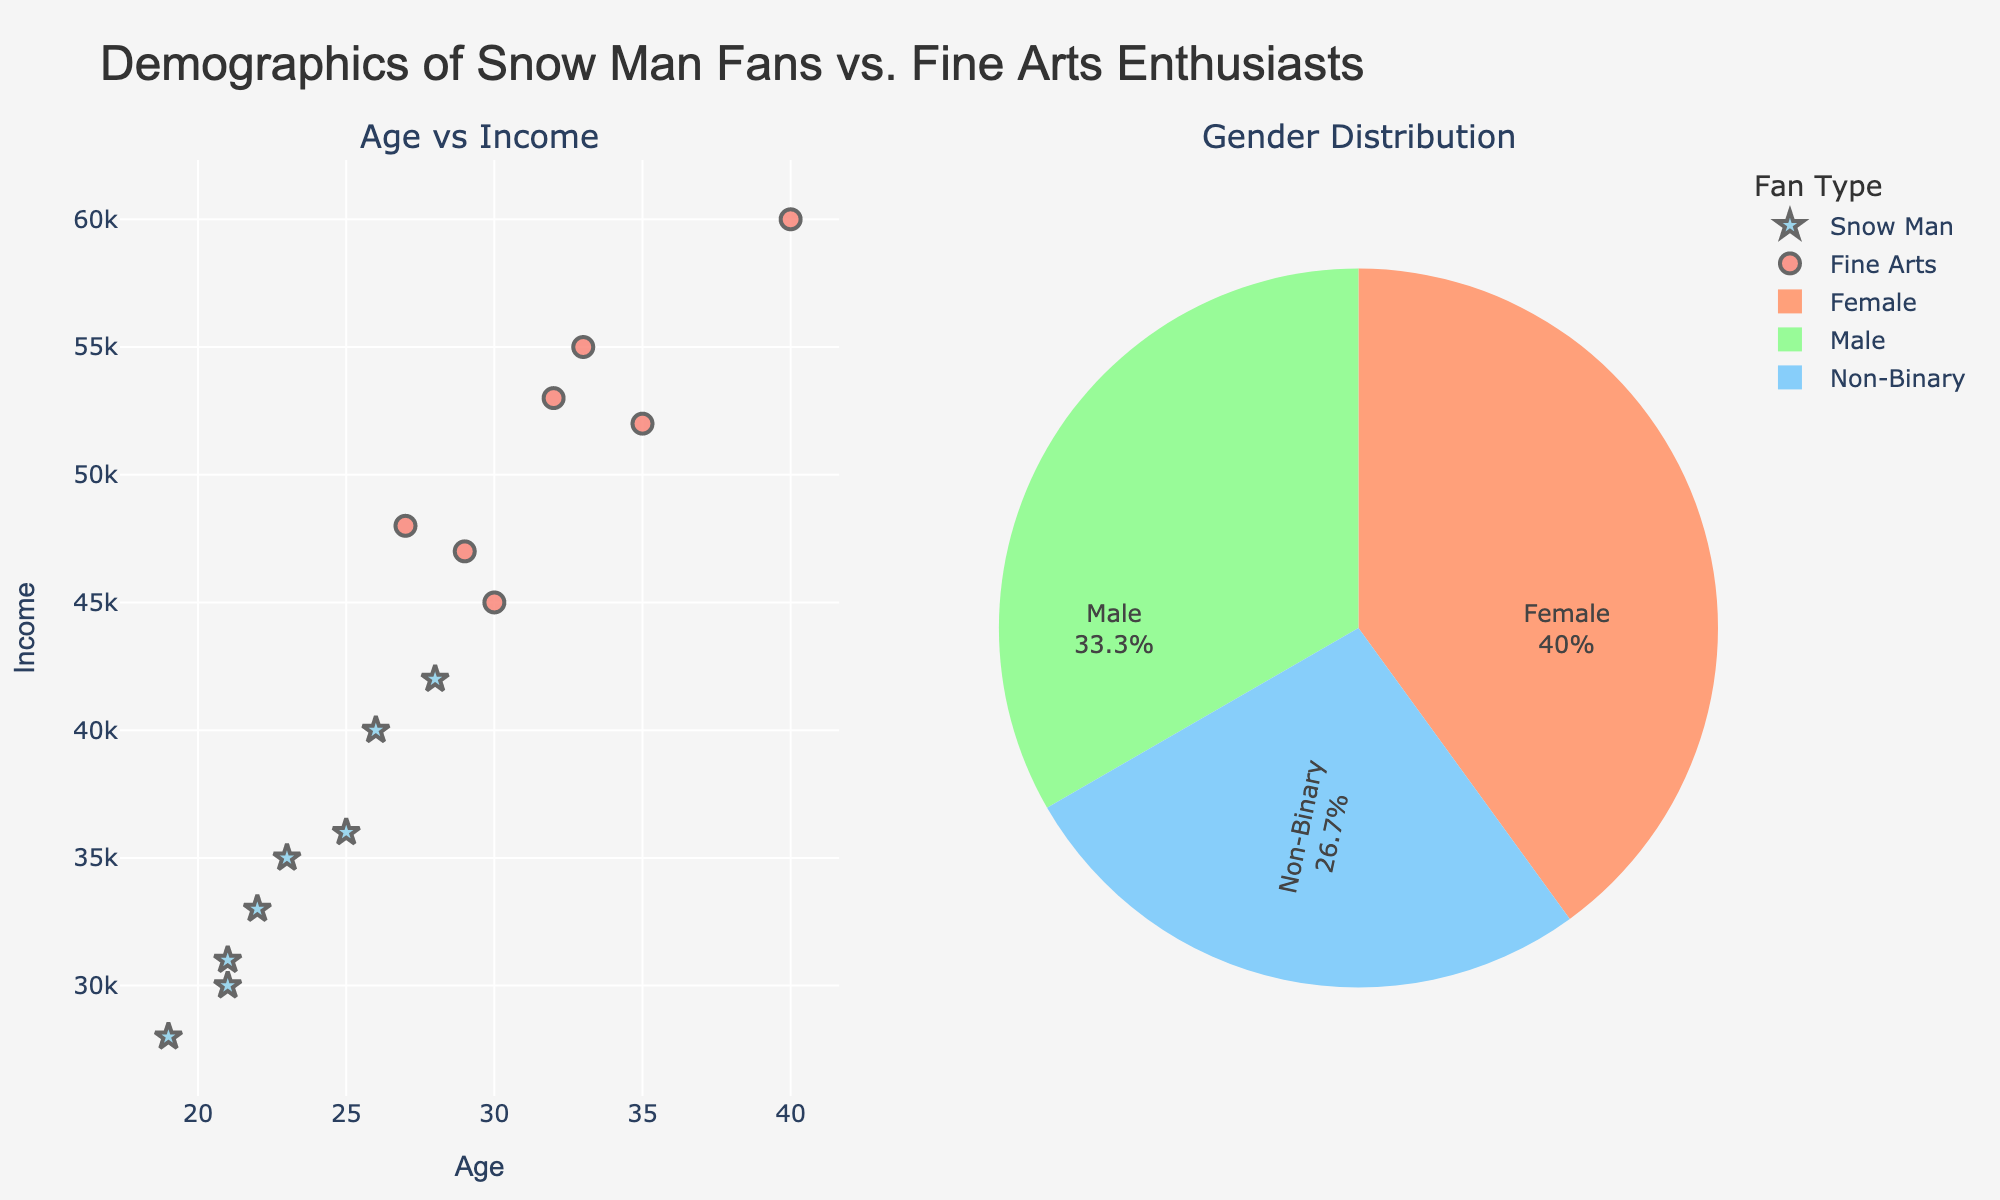What is the title of the plot? The title of the plot can be found at the top center of the figure. It reads "Demographics of Snow Man Fans vs. Fine Arts Enthusiasts".
Answer: Demographics of Snow Man Fans vs. Fine Arts Enthusiasts What does the X-axis represent in the scatter plot? The X-axis in the scatter plot represents the "Age" of the individuals. This can be seen in the labeling along the horizontal axis.
Answer: Age What are the shapes of the markers used to represent Snow Man fans and Fine Arts enthusiasts on the scatter plot? The Snow Man fans are indicated by star-shaped markers, whereas Fine Arts enthusiasts are shown using circle-shaped markers. This differentiation helps to visually separate the two groups.
Answer: Stars and circles Which group has a higher overall income range, Snow Man fans or Fine Arts enthusiasts? By examining the Y-axis values of the scatter plot, Fine Arts enthusiasts have higher overall income levels, ranging from 45000 to 60000, compared to Snow Man fans whose income levels range from 28000 to 42000.
Answer: Fine Arts enthusiasts What percentage of the total gender distribution are female? The pie chart displays the gender distribution. By assessing the "female" section within the pie chart, you can see the proportion marked in the chart.
Answer: 46.7% What is the average age of Fine Arts enthusiasts? To find the average age of Fine Arts enthusiasts, locate the ages of Fine Arts enthusiasts on the scatter plot and sum up the ages: 30, 35, 40, 33, 27, 29, 32. Then divide by the number of data points (7). \( (30 + 35 + 40 + 33 + 27 + 29 + 32) / 7 = 32.29 \)
Answer: 32.29 What is the most common gender identified in the data? From the pie chart showing the gender distribution, observe which section has the largest percentage. The largest section corresponds to females.
Answer: Female Compare the highest income between Snow Man fans and Fine Arts enthusiasts. Investigate the highest points on the Y-axis of the scatter plot for both groups. Snow Man fans' highest income is at 42000, while Fine Arts enthusiasts' highest income reaches 60000.
Answer: Fine Arts enthusiasts How does the average income of Snow Man fans compare to that of Fine Arts enthusiasts? Calculate the average income for each group: for Snow Man fans (28000 + 35000 + 30000 + 40000 + 42000 + 33000 + 36000 + 31000)/8 = 34375. For Fine Arts enthusiasts (45000 + 52000 + 60000 + 55000 + 48000 + 47000 + 53000)/7 = 51428.57. Comparing these averages reveals Fine Arts enthusiasts have a higher average income.
Answer: Fine Arts enthusiasts have a higher average income Which gender is least represented in the data? Refer to the pie chart for gender distribution. The smallest section belongs to Non-Binary individuals.
Answer: Non-Binary 